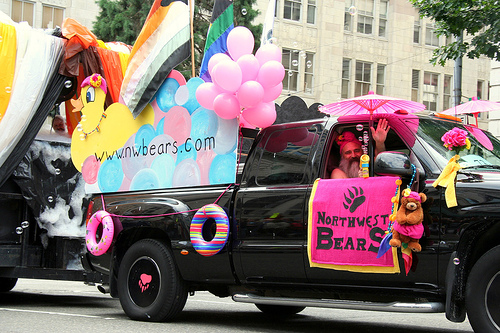<image>
Is the car next to the baloons? No. The car is not positioned next to the baloons. They are located in different areas of the scene. Is the baloons in the sign? No. The baloons is not contained within the sign. These objects have a different spatial relationship. 